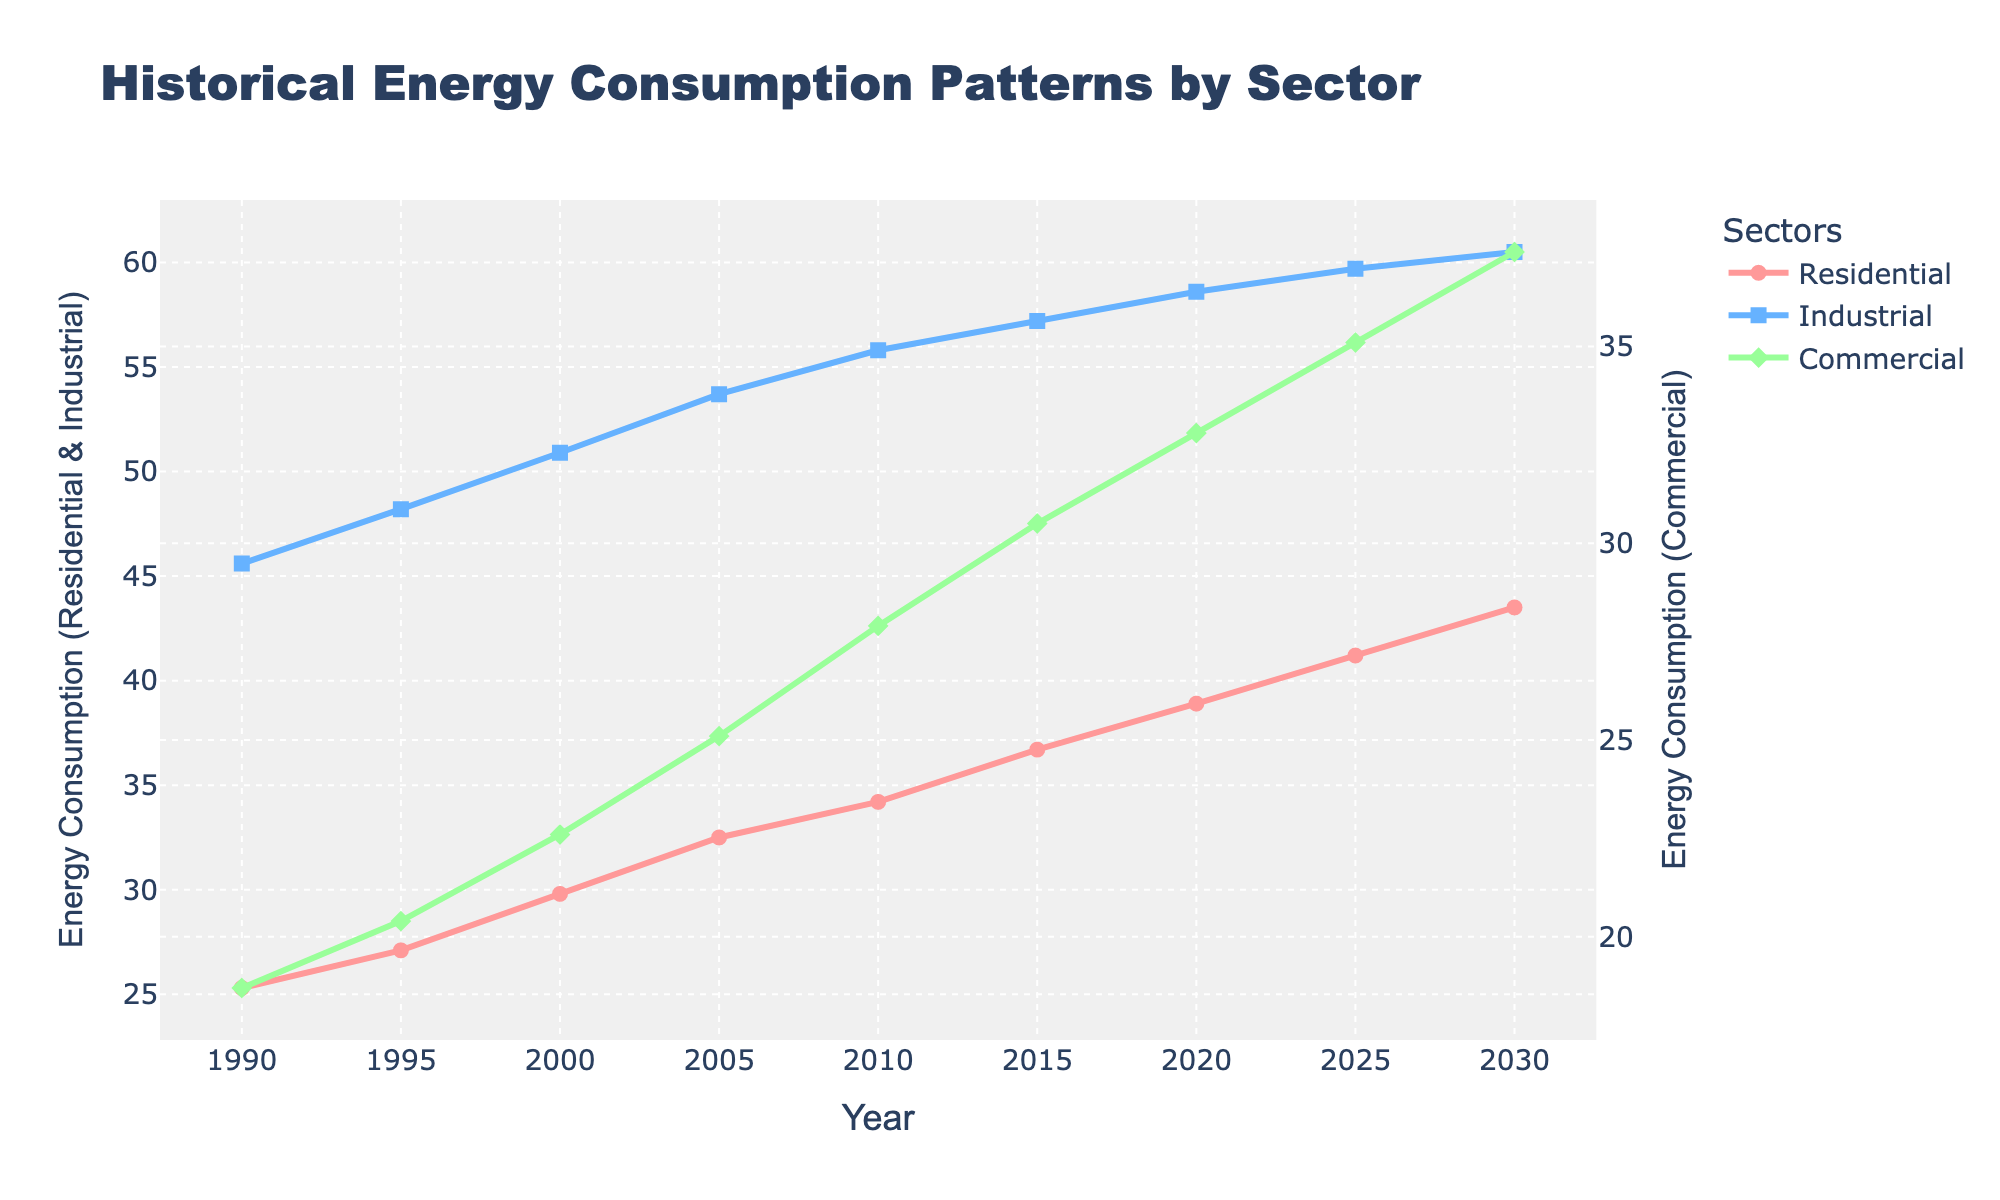What's the total energy consumption for all three sectors in 2000? First, find the energy consumption values for Residential (29.8), Industrial (50.9), and Commercial (22.6) in 2000 from the figure. Then, add them up: 29.8 + 50.9 + 22.6 = 103.3.
Answer: 103.3 Which sector had the greatest increase in energy consumption from 1990 to 2030? From the figure, note the Residential sector increased from 25.3 to 43.5, the Industrial sector from 45.6 to 60.5, and the Commercial sector from 18.7 to 37.4. Calculate the differences: Residential (43.5 - 25.3 = 18.2), Industrial (60.5 - 45.6 = 14.9), Commercial (37.4 - 18.7 = 18.7). Compare the increase: Commercial has the greatest increase (18.7).
Answer: Commercial In which year did the residential sector's energy consumption surpass 35 units? Look at the figure to identify the year where the Residential line first crosses 35 units. It occurs between 2010 (34.2) and 2015 (36.7). Thus, it is 2015.
Answer: 2015 What is the average energy consumption in the Commercial sector over the years provided? Find the commercial values: 18.7, 20.4, 22.6, 25.1, 27.9, 30.5, 32.8, 35.1, 37.4. Sum these values and divide by the number of data points (9): (221.5 / 9) = 24.61 (rounded to two decimal places).
Answer: 24.61 Between 2010 and 2020, which sector shows the smallest growth in energy consumption? From the figure, note the values for each sector in 2010 and 2020. Calculate the growth: Residential (38.9 - 34.2 = 4.7), Industrial (58.6 - 55.8 = 2.8), Commercial (32.8 - 27.9 = 4.9). Compare the growth: Industrial has the smallest growth of 2.8 units.
Answer: Industrial How does the visual representation of Commercial energy consumption differ from the other sectors? The Commercial sector is represented by a green line with diamond markers, while the Residential and Industrial sectors use red and blue lines with circle and square markers, respectively. The Commercial consumption also has its own y-axis on the right.
Answer: Different color and markers, separate y-axis 